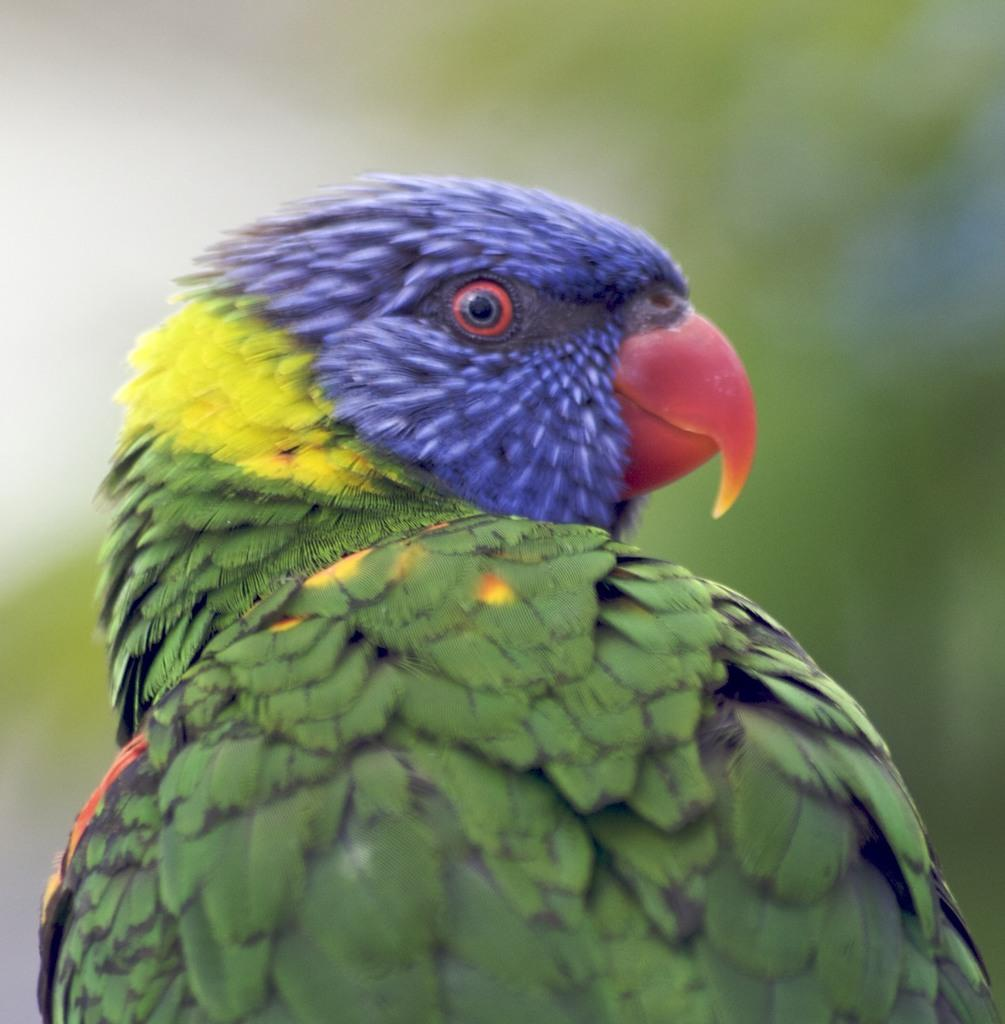What type of animal is in the image? There is a bird in the image. Can you describe the background of the image? The background of the image is blurry. What type of cheese can be seen on the coast in the image? There is no cheese or coast present in the image; it features a bird with a blurry background. Can you see a giraffe in the image? No, there is no giraffe present in the image; it features a bird with a blurry background. 